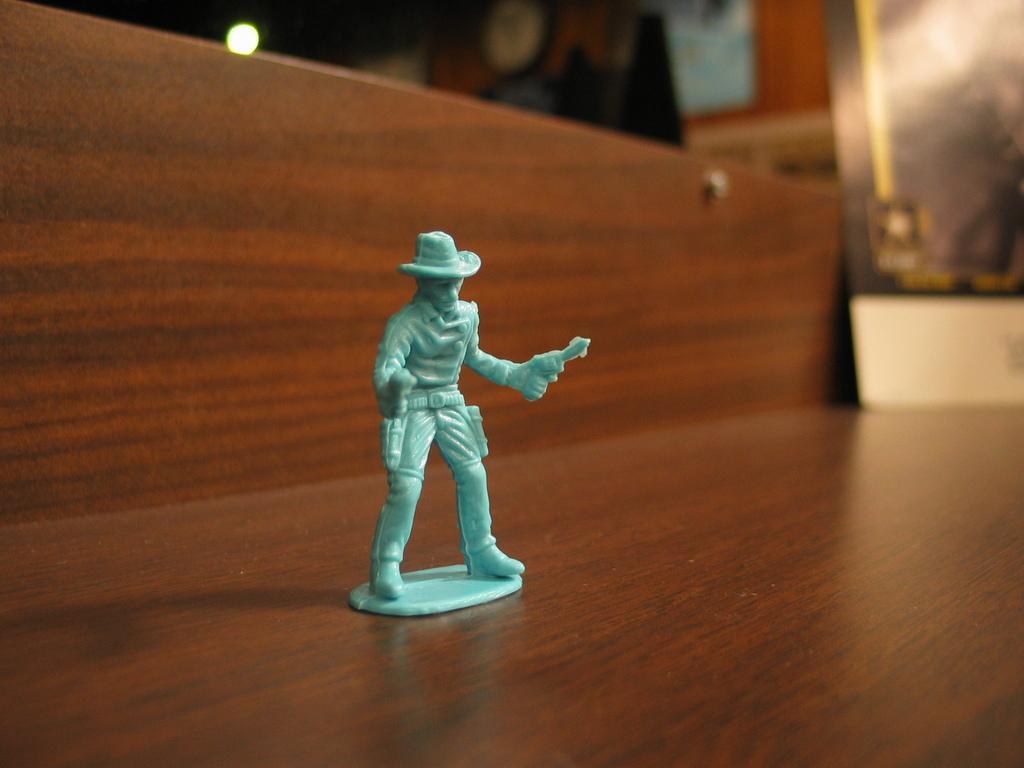How would you summarize this image in a sentence or two? In this image I can see a green colour toy over here. In the background I can see a thing and I can also see this image is little bit blurry from background. 